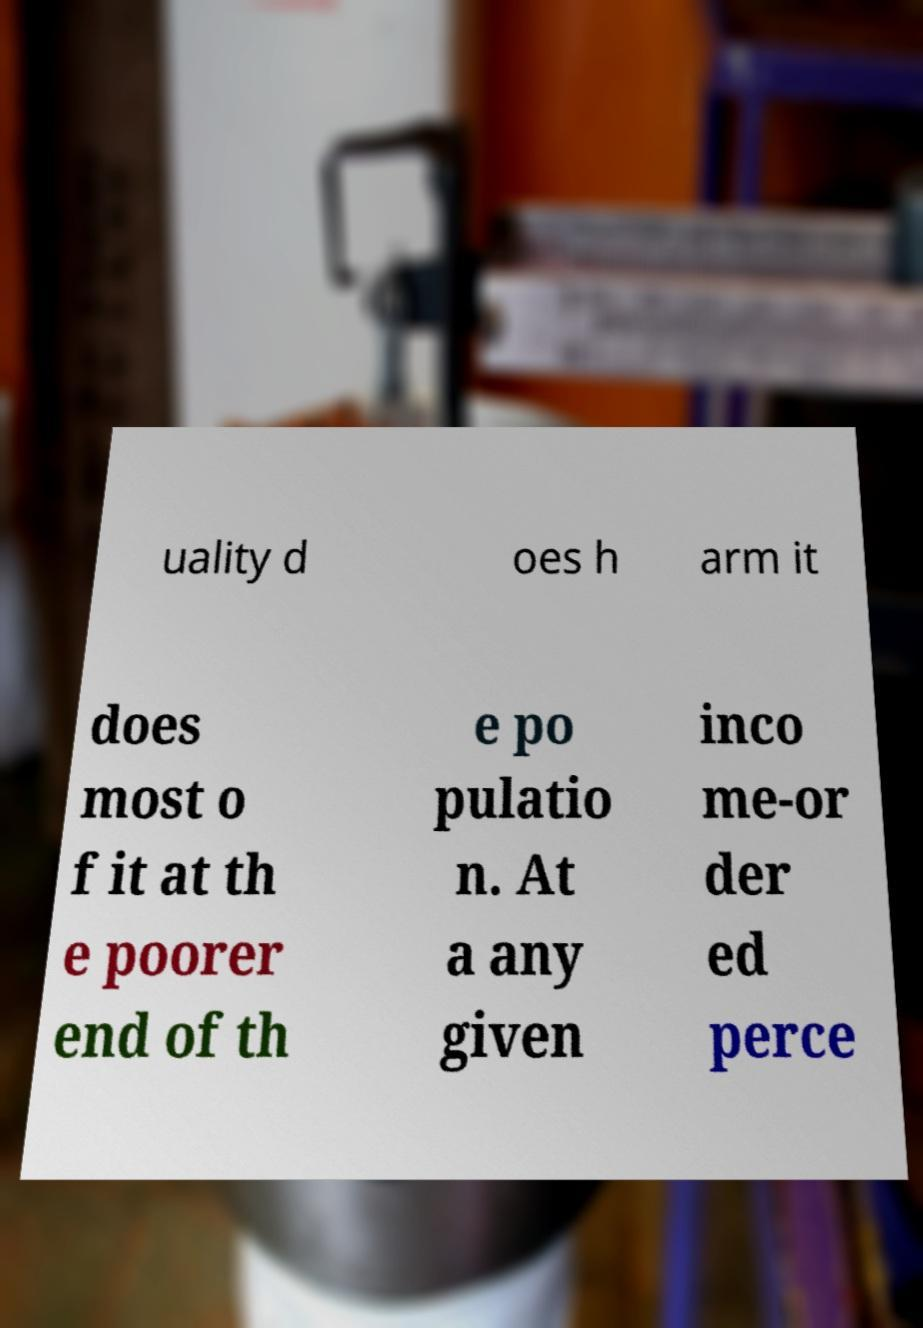For documentation purposes, I need the text within this image transcribed. Could you provide that? uality d oes h arm it does most o f it at th e poorer end of th e po pulatio n. At a any given inco me-or der ed perce 